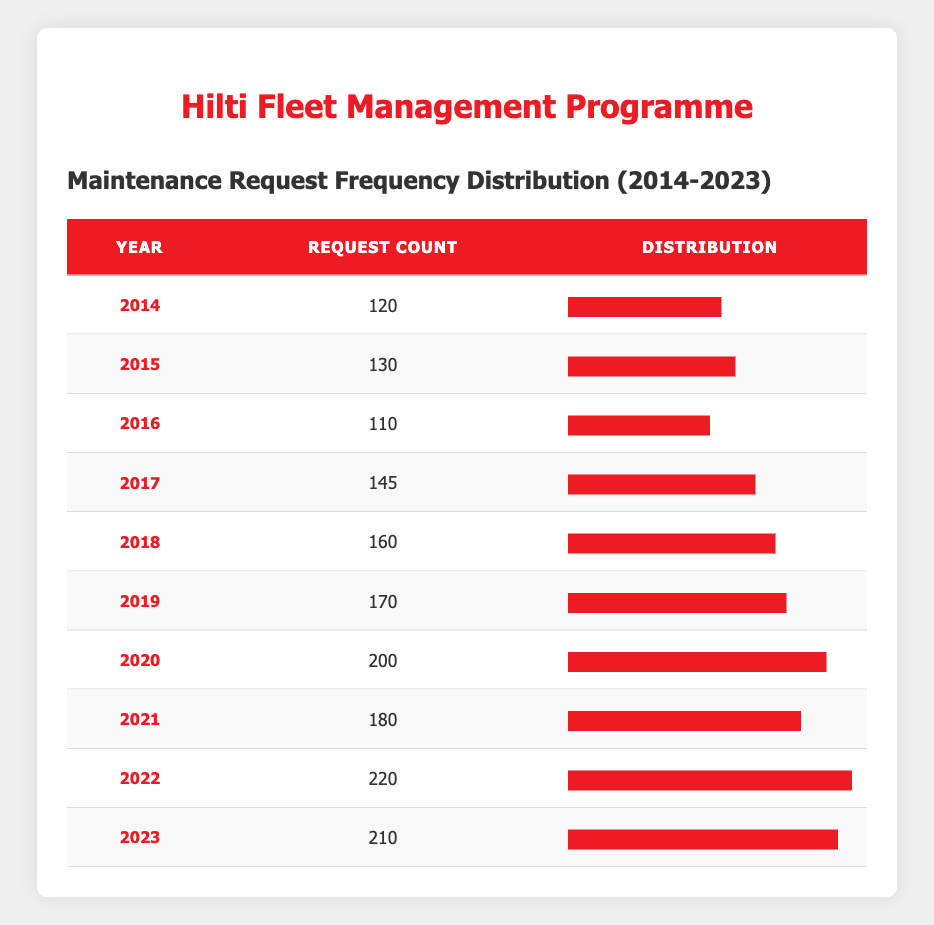What year had the highest number of maintenance requests? Looking at the request count for each year, 2022 has the highest number at 220.
Answer: 2022 What was the maintenance request count in 2016? The table shows that in 2016, the request count was 110.
Answer: 110 How many requests were submitted from 2014 to 2019 combined? To find the total from 2014 to 2019, we sum the request counts: 120 + 130 + 110 + 145 + 160 + 170 = 935.
Answer: 935 Was there a decrease in maintenance requests from 2019 to 2020? In 2019, the request count was 170, and in 2020, it increased to 200. Therefore, there was no decrease.
Answer: No What is the average number of maintenance requests over the 10 years? We need to sum all the request counts: 120 + 130 + 110 + 145 + 160 + 170 + 200 + 180 + 220 + 210 = 1,575. There are 10 years, so the average is 1,575 / 10 = 157.5.
Answer: 157.5 Which year had a request count closest to the average of the counts recorded? The average is 157.5. The years with request counts closest to this value are 2015 (130) and 2018 (160).
Answer: 2015 and 2018 Did the maintenance requests ever exceed 200 during the period? Yes, the numbers for 2020 (200), 2022 (220), and 2023 (210) all exceed 200.
Answer: Yes What was the change in the request count from 2021 to 2022? In 2021, there were 180 requests and in 2022, there were 220 requests. The change is 220 - 180 = 40.
Answer: 40 Which two years had the closest number of maintenance requests? The years 2021 and 2020 had counts of 180 and 200 respectively, which are the closest when compared to other differences in counts.
Answer: 2021 and 2020 